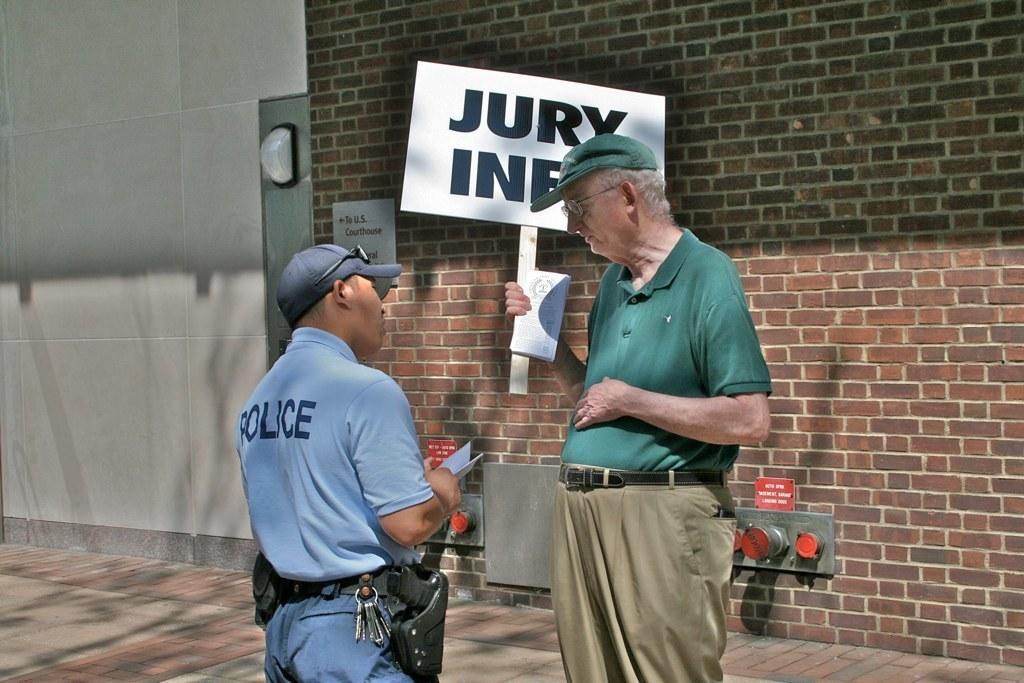Could you give a brief overview of what you see in this image? In this picture there are people standing, among them there's a man holding a stick with board and book. In the background of the image we can see boards and wall. 